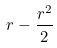Convert formula to latex. <formula><loc_0><loc_0><loc_500><loc_500>r - \frac { r ^ { 2 } } { 2 }</formula> 